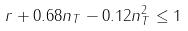<formula> <loc_0><loc_0><loc_500><loc_500>r + 0 . 6 8 n _ { T } - 0 . 1 2 n _ { T } ^ { 2 } \leq 1</formula> 